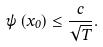Convert formula to latex. <formula><loc_0><loc_0><loc_500><loc_500>\psi \left ( x _ { 0 } \right ) \leq \frac { c } { \sqrt { T } } .</formula> 